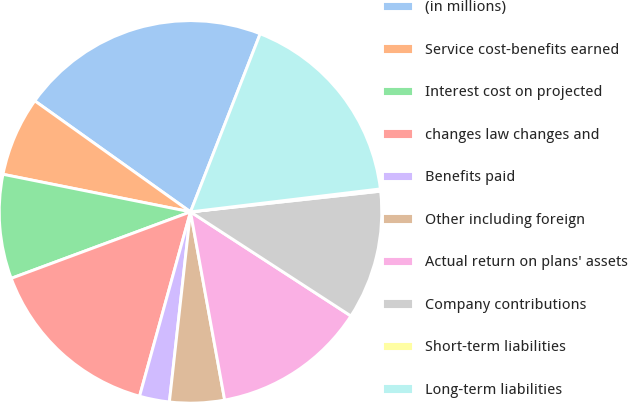Convert chart to OTSL. <chart><loc_0><loc_0><loc_500><loc_500><pie_chart><fcel>(in millions)<fcel>Service cost-benefits earned<fcel>Interest cost on projected<fcel>changes law changes and<fcel>Benefits paid<fcel>Other including foreign<fcel>Actual return on plans' assets<fcel>Company contributions<fcel>Short-term liabilities<fcel>Long-term liabilities<nl><fcel>21.08%<fcel>6.71%<fcel>8.8%<fcel>15.06%<fcel>2.53%<fcel>4.62%<fcel>12.98%<fcel>10.89%<fcel>0.19%<fcel>17.15%<nl></chart> 